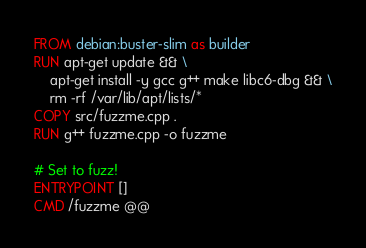Convert code to text. <code><loc_0><loc_0><loc_500><loc_500><_Dockerfile_>FROM debian:buster-slim as builder
RUN apt-get update && \
    apt-get install -y gcc g++ make libc6-dbg && \
    rm -rf /var/lib/apt/lists/*
COPY src/fuzzme.cpp .
RUN g++ fuzzme.cpp -o fuzzme

# Set to fuzz!
ENTRYPOINT []
CMD /fuzzme @@
</code> 